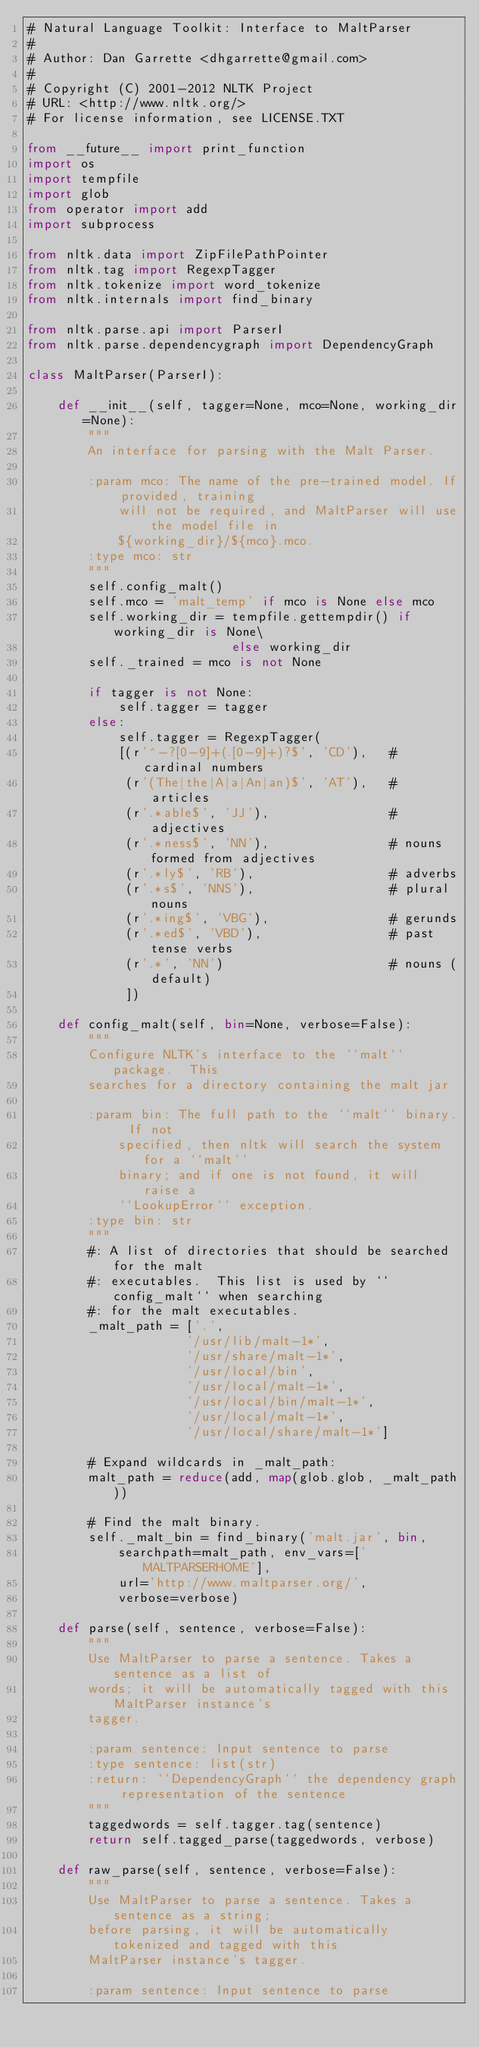<code> <loc_0><loc_0><loc_500><loc_500><_Python_># Natural Language Toolkit: Interface to MaltParser
#
# Author: Dan Garrette <dhgarrette@gmail.com>
#
# Copyright (C) 2001-2012 NLTK Project
# URL: <http://www.nltk.org/>
# For license information, see LICENSE.TXT

from __future__ import print_function
import os
import tempfile
import glob
from operator import add
import subprocess

from nltk.data import ZipFilePathPointer
from nltk.tag import RegexpTagger
from nltk.tokenize import word_tokenize
from nltk.internals import find_binary

from nltk.parse.api import ParserI
from nltk.parse.dependencygraph import DependencyGraph

class MaltParser(ParserI):

    def __init__(self, tagger=None, mco=None, working_dir=None):
        """
        An interface for parsing with the Malt Parser.

        :param mco: The name of the pre-trained model. If provided, training
            will not be required, and MaltParser will use the model file in
            ${working_dir}/${mco}.mco.
        :type mco: str
        """
        self.config_malt()
        self.mco = 'malt_temp' if mco is None else mco
        self.working_dir = tempfile.gettempdir() if working_dir is None\
                           else working_dir
        self._trained = mco is not None

        if tagger is not None:
            self.tagger = tagger
        else:
            self.tagger = RegexpTagger(
            [(r'^-?[0-9]+(.[0-9]+)?$', 'CD'),   # cardinal numbers
             (r'(The|the|A|a|An|an)$', 'AT'),   # articles
             (r'.*able$', 'JJ'),                # adjectives
             (r'.*ness$', 'NN'),                # nouns formed from adjectives
             (r'.*ly$', 'RB'),                  # adverbs
             (r'.*s$', 'NNS'),                  # plural nouns
             (r'.*ing$', 'VBG'),                # gerunds
             (r'.*ed$', 'VBD'),                 # past tense verbs
             (r'.*', 'NN')                      # nouns (default)
             ])

    def config_malt(self, bin=None, verbose=False):
        """
        Configure NLTK's interface to the ``malt`` package.  This
        searches for a directory containing the malt jar

        :param bin: The full path to the ``malt`` binary.  If not
            specified, then nltk will search the system for a ``malt``
            binary; and if one is not found, it will raise a
            ``LookupError`` exception.
        :type bin: str
        """
        #: A list of directories that should be searched for the malt
        #: executables.  This list is used by ``config_malt`` when searching
        #: for the malt executables.
        _malt_path = ['.',
                     '/usr/lib/malt-1*',
                     '/usr/share/malt-1*',
                     '/usr/local/bin',
                     '/usr/local/malt-1*',
                     '/usr/local/bin/malt-1*',
                     '/usr/local/malt-1*',
                     '/usr/local/share/malt-1*']

        # Expand wildcards in _malt_path:
        malt_path = reduce(add, map(glob.glob, _malt_path))

        # Find the malt binary.
        self._malt_bin = find_binary('malt.jar', bin,
            searchpath=malt_path, env_vars=['MALTPARSERHOME'],
            url='http://www.maltparser.org/',
            verbose=verbose)

    def parse(self, sentence, verbose=False):
        """
        Use MaltParser to parse a sentence. Takes a sentence as a list of
        words; it will be automatically tagged with this MaltParser instance's
        tagger.

        :param sentence: Input sentence to parse
        :type sentence: list(str)
        :return: ``DependencyGraph`` the dependency graph representation of the sentence
        """
        taggedwords = self.tagger.tag(sentence)
        return self.tagged_parse(taggedwords, verbose)

    def raw_parse(self, sentence, verbose=False):
        """
        Use MaltParser to parse a sentence. Takes a sentence as a string;
        before parsing, it will be automatically tokenized and tagged with this
        MaltParser instance's tagger.

        :param sentence: Input sentence to parse</code> 